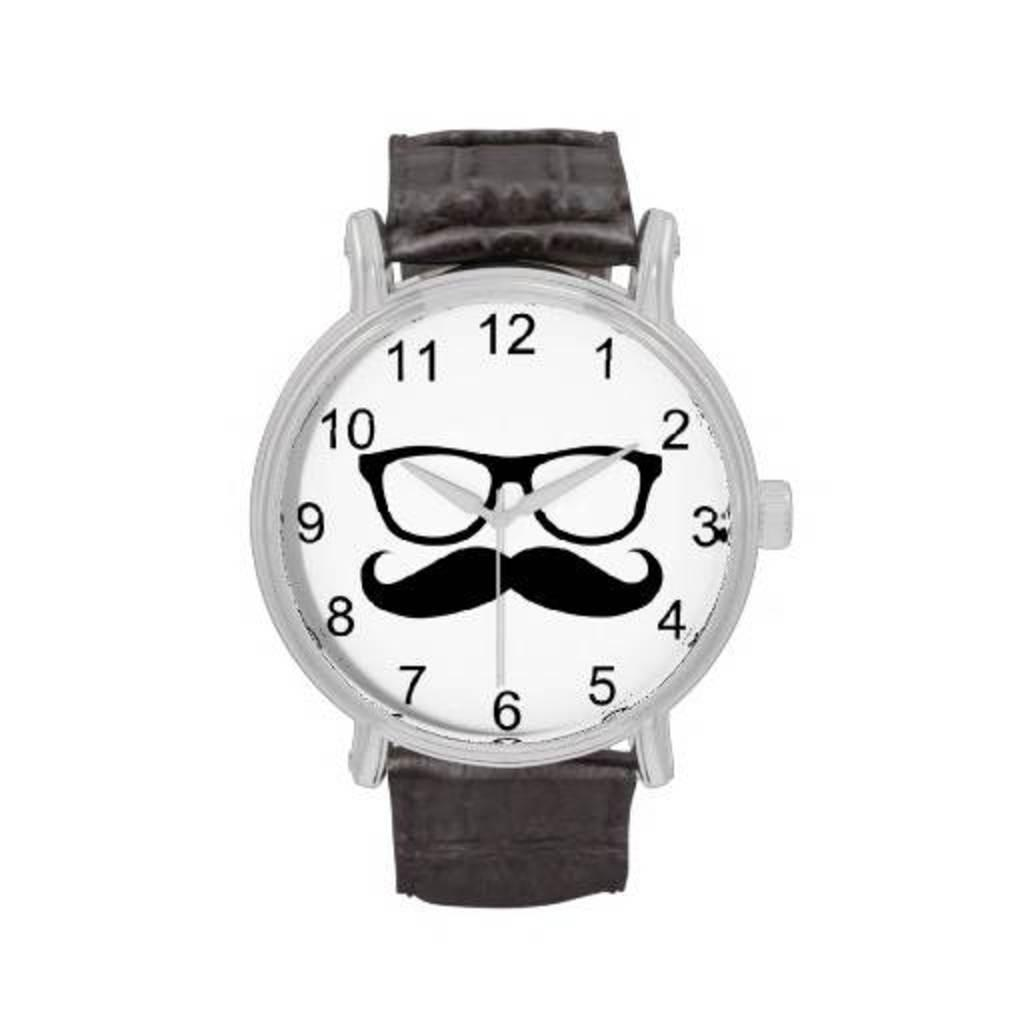What object in the picture is used for telling time? There is a watch in the picture that is used for telling time. What material is used for the watch's belt? The watch has a leather belt. What type of markings are on the watch? The watch has numbers on it. What other object related to vision can be seen in the picture? There is a spectacle in the picture. What is the third object in the picture? There is a mustache stamp in the picture. How does the watch feel about the debt it has accumulated in the image? The watch is an inanimate object and does not have feelings or debt. 